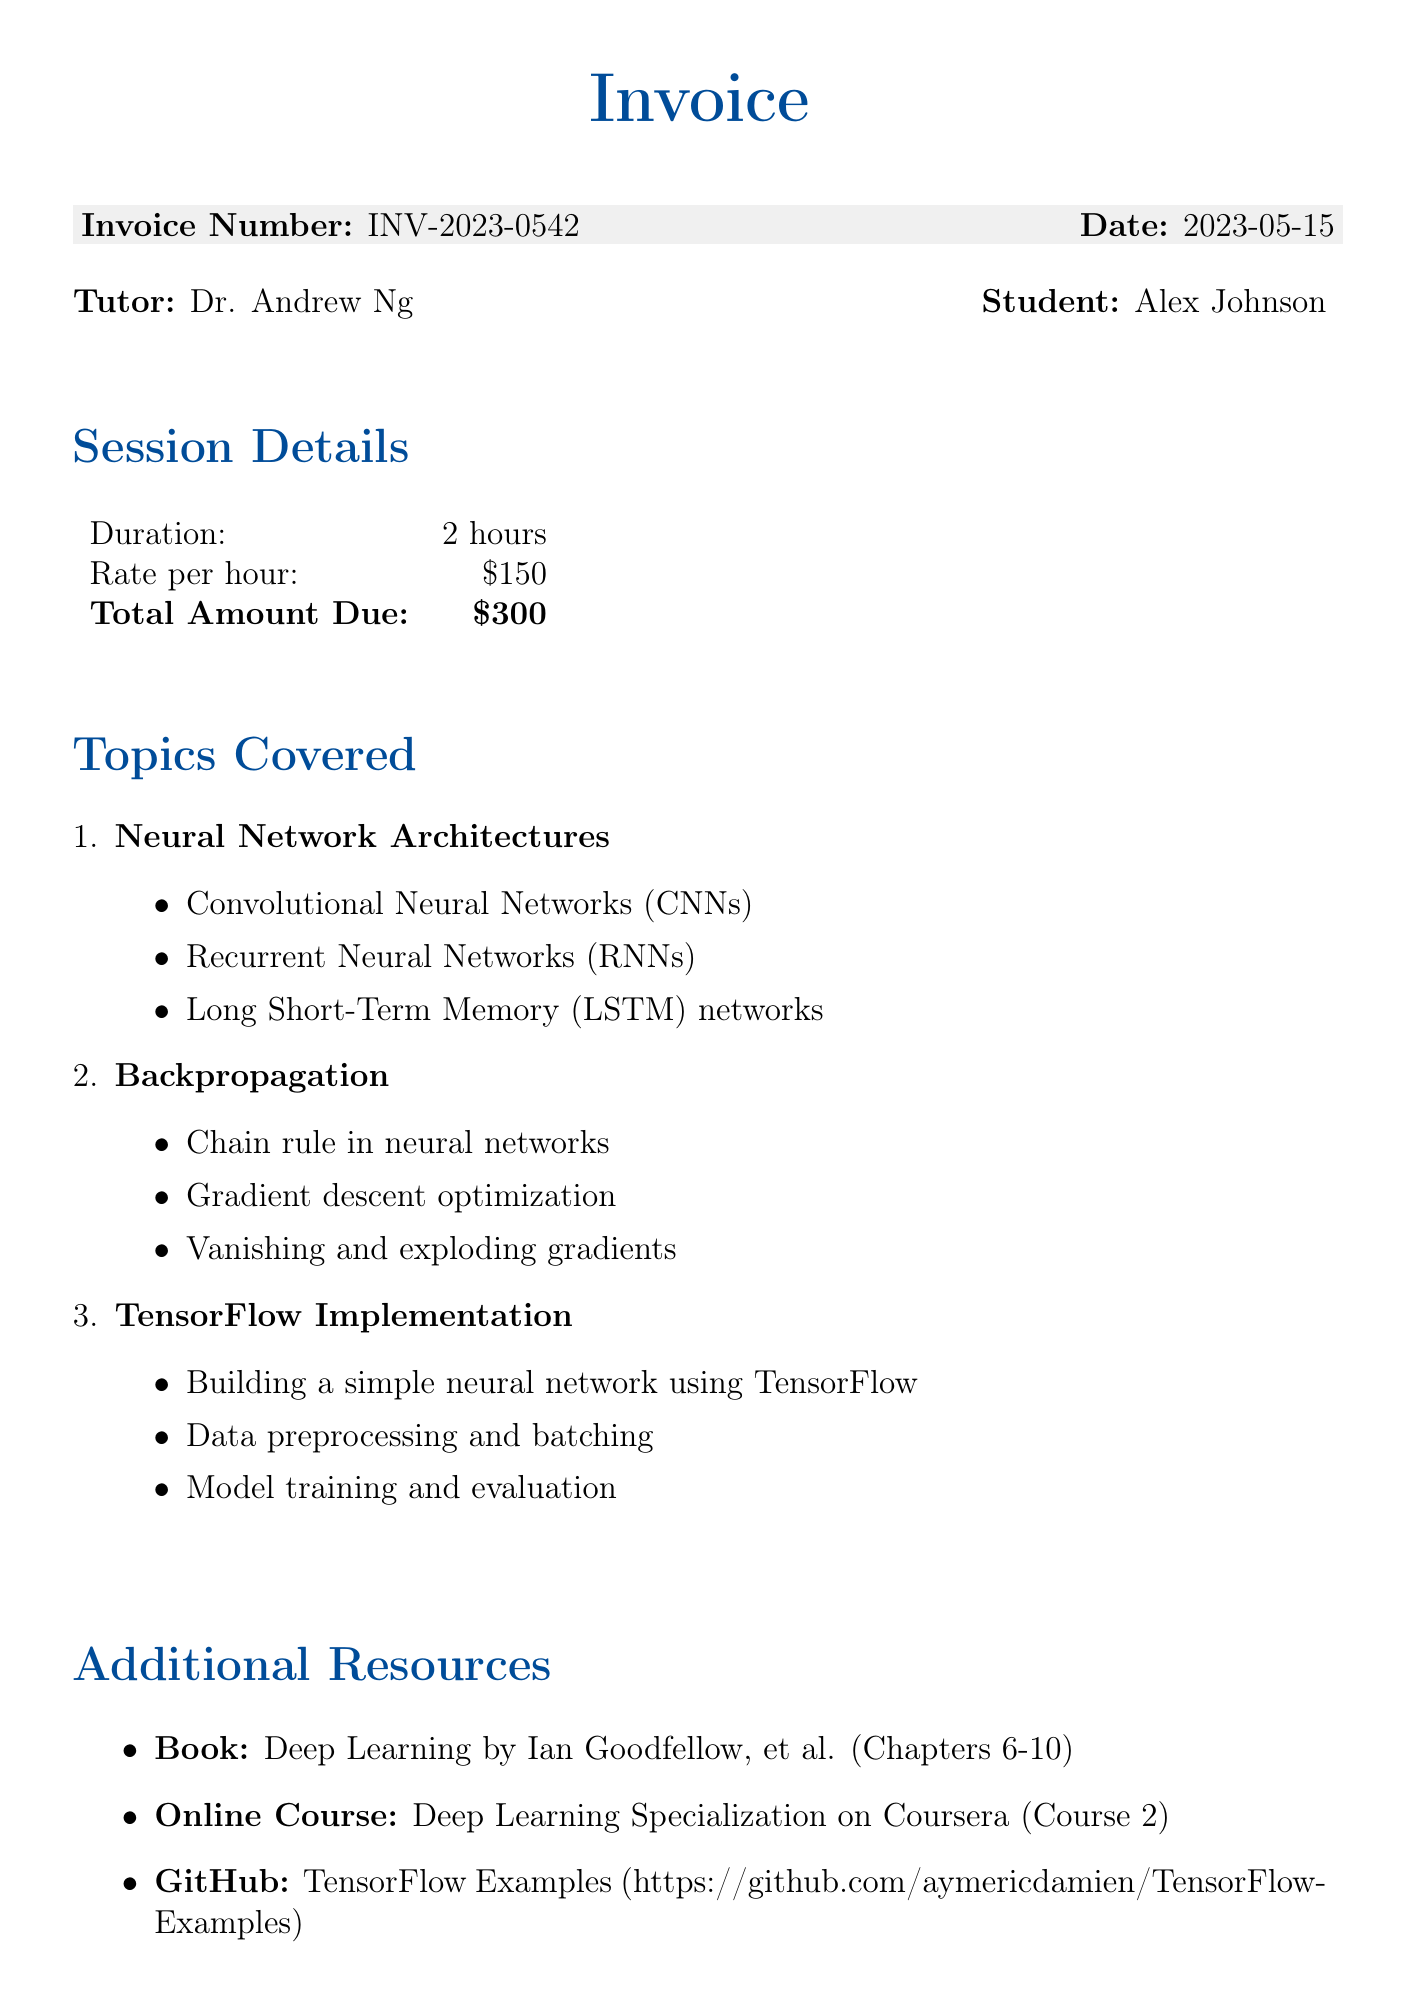What is the invoice number? The invoice number is a unique identifier for the bill and can be found in the document.
Answer: INV-2023-0542 Who is the tutor? The tutor's name is listed at the top of the document.
Answer: Dr. Andrew Ng What is the duration of the tutoring session? The duration is specified in the session details section.
Answer: 2 hours What is the total amount due? The total amount is mentioned in the session details alongside the rate per hour.
Answer: $300 What is one of the main topics covered in the session? The document lists several main topics that were discussed during the session.
Answer: Neural Network Architectures What is the due date for payment? The payment details section specifies when the payment must be made.
Answer: 2023-05-22 What late fee applies if payment is made after the due date? The document outlines the penalty for late payments in the payment details section.
Answer: 5% of total amount if paid after due date What are the proposed topics for the next session? The next session's topics are listed at the end of the document.
Answer: Advanced optimization techniques, Transfer learning, Generative Adversarial Networks Which online course is recommended for further learning? The additional resources section includes recommendations for further study.
Answer: Deep Learning Specialization on Coursera 